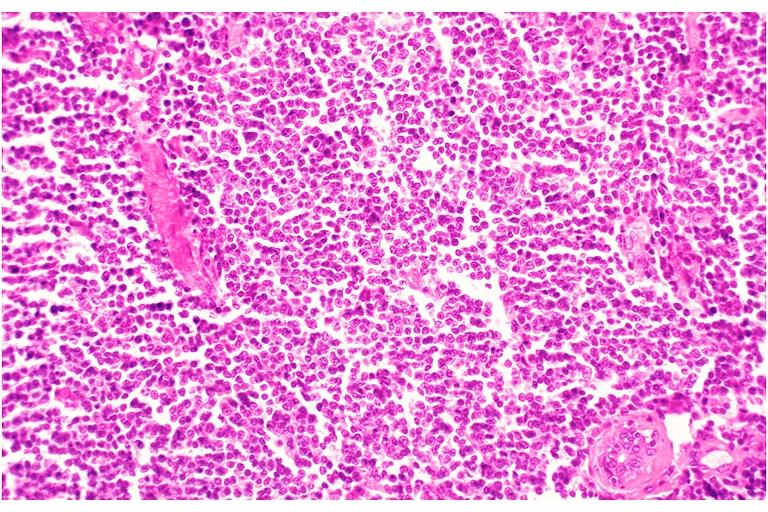where is this?
Answer the question using a single word or phrase. Oral 